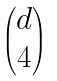Convert formula to latex. <formula><loc_0><loc_0><loc_500><loc_500>\begin{pmatrix} d \\ 4 \end{pmatrix}</formula> 